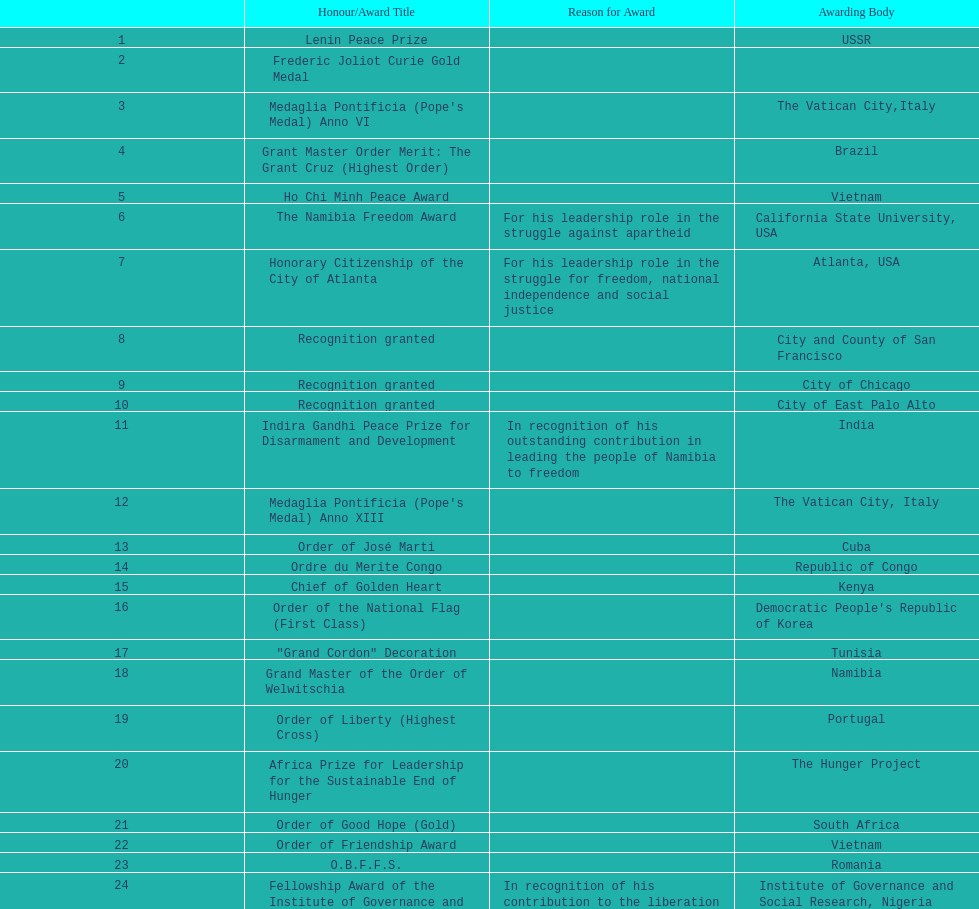The number of times "recognition granted" was the received award? 3. 